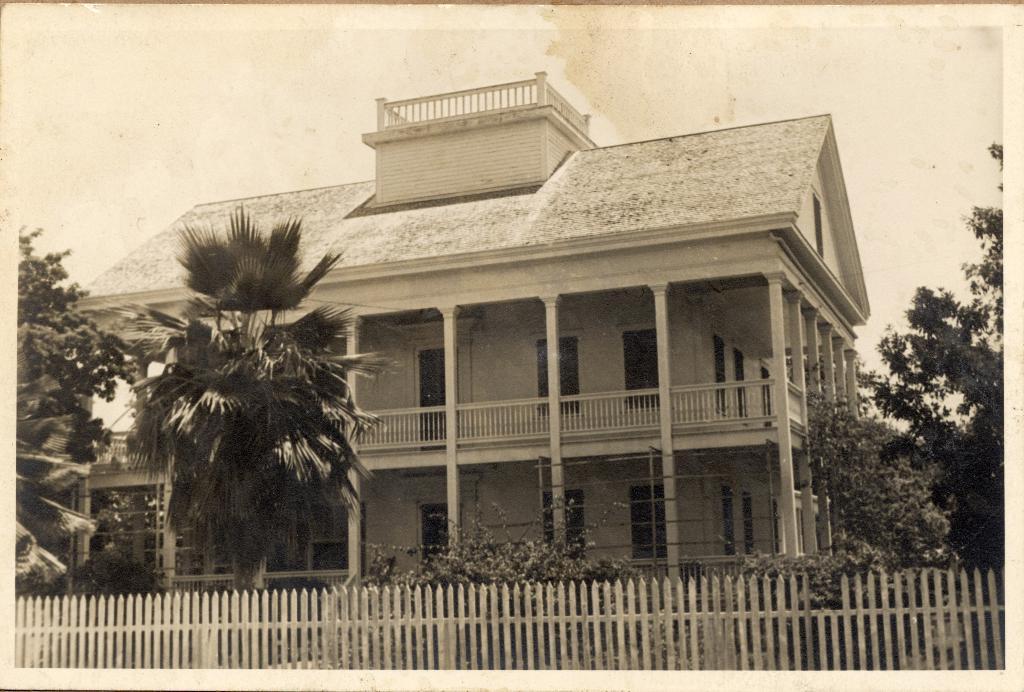In one or two sentences, can you explain what this image depicts? At the bottom we can see fence and there are plants and trees. In the background there is a building, doors, poles, roof and we can see the sky. 